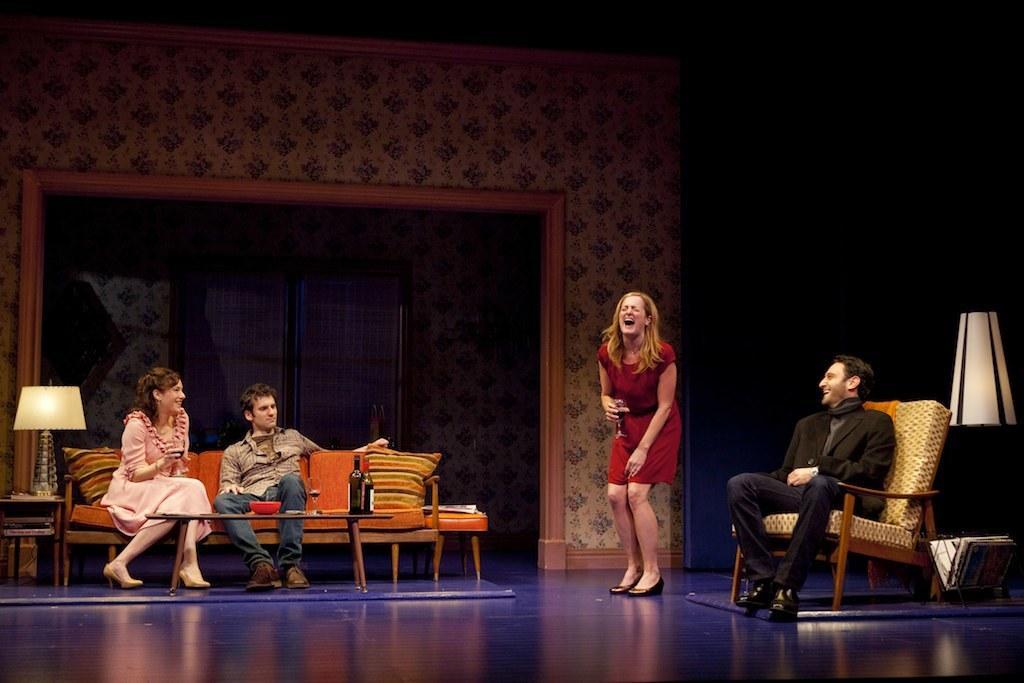Please provide a concise description of this image. In this picture I can see a person sitting on the chair on the right side. I can see a person holding wine glass and standing on the surface. I can see two people sitting on the sofa. I can see bottles on the table. I can see table lamps on the both left and right sides. 